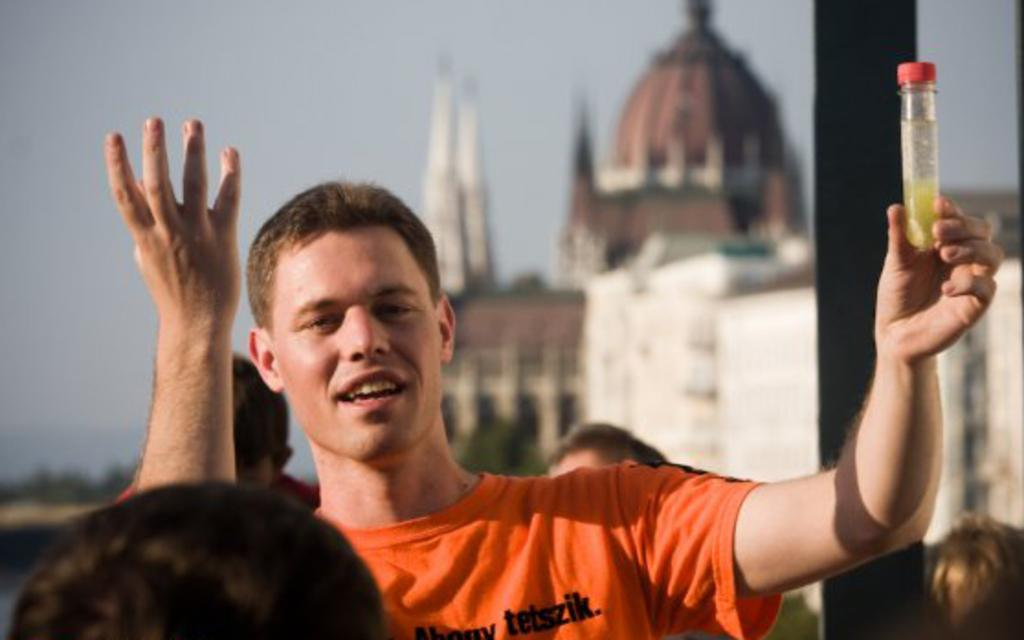How many people are in the image? There are people in the image. What is one person holding in the image? One person is holding a bottle. What can be seen in the image besides people? There is a pole, a house, and the sky visible in the image. What is the condition of the background in the image? The background is blurred in the image. What type of father-son activity can be seen in the image? There is no father or son present in the image, and therefore no such activity can be observed. Can you tell me how many monkeys are climbing the pole in the image? There are no monkeys present in the image; it features people, a pole, a house, and the sky. 